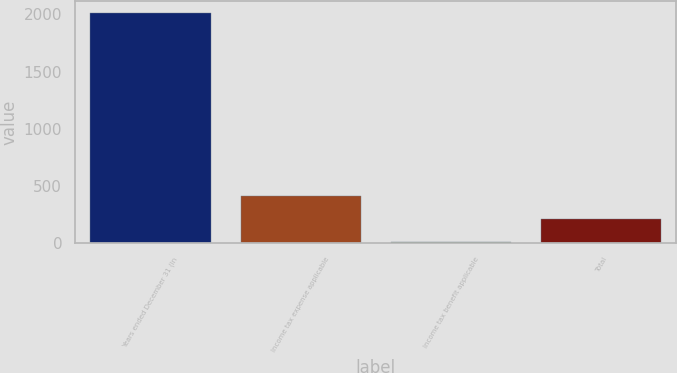Convert chart. <chart><loc_0><loc_0><loc_500><loc_500><bar_chart><fcel>Years ended December 31 (in<fcel>Income tax expense applicable<fcel>Income tax benefit applicable<fcel>Total<nl><fcel>2014<fcel>408.16<fcel>6.7<fcel>207.43<nl></chart> 